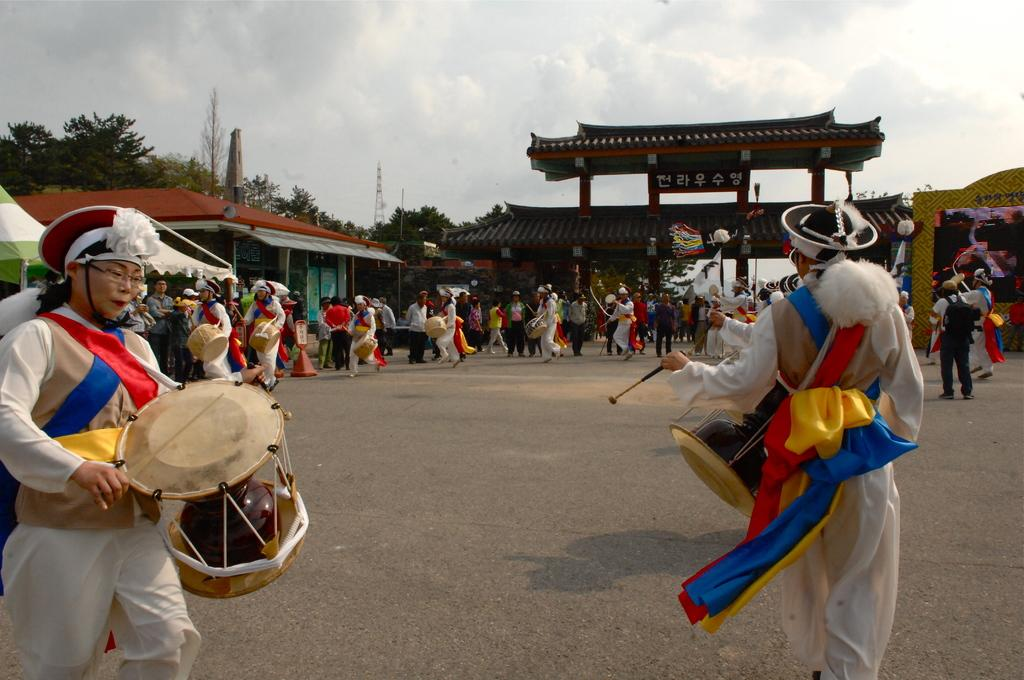How many people are in the image? There is a group of people in the image. What are two of the people holding? Two men are holding drums in their hands. What type of structure can be seen in the image? There is a building in the image. What type of vegetation is present in the image? There are trees in the image. What is visible in the sky in the image? Clouds are visible in the sky. Can you see any pets playing on the seashore in the image? There is no seashore or pets present in the image. 